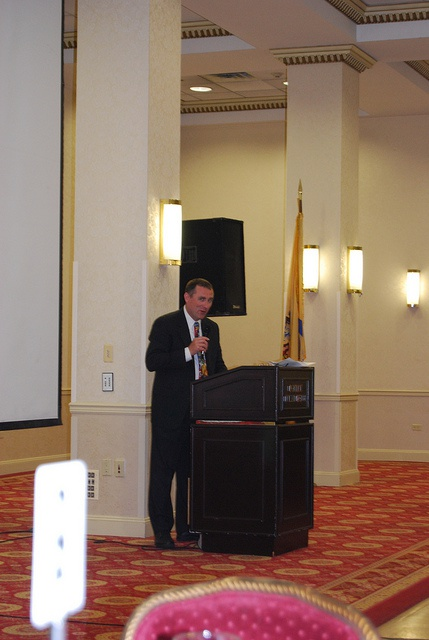Describe the objects in this image and their specific colors. I can see chair in gray, brown, and violet tones, people in gray, black, brown, maroon, and darkgray tones, and tie in gray, black, maroon, and olive tones in this image. 